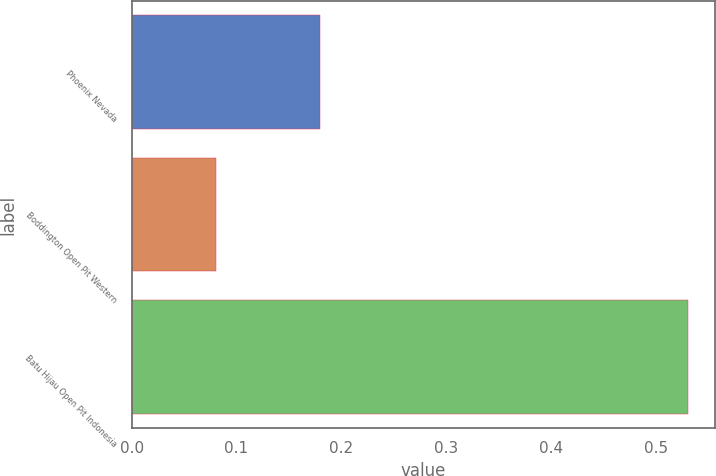Convert chart to OTSL. <chart><loc_0><loc_0><loc_500><loc_500><bar_chart><fcel>Phoenix Nevada<fcel>Boddington Open Pit Western<fcel>Batu Hijau Open Pit Indonesia<nl><fcel>0.18<fcel>0.08<fcel>0.53<nl></chart> 